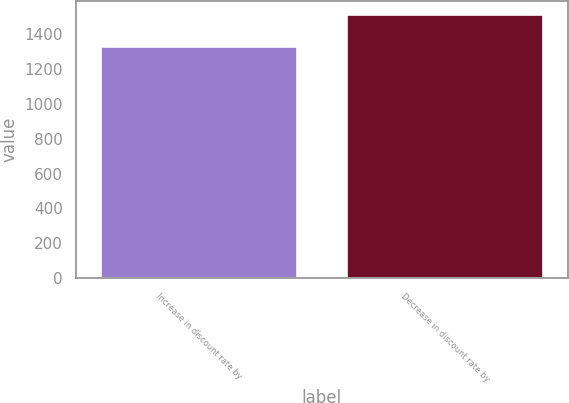Convert chart to OTSL. <chart><loc_0><loc_0><loc_500><loc_500><bar_chart><fcel>Increase in discount rate by<fcel>Decrease in discount rate by<nl><fcel>1333<fcel>1515<nl></chart> 